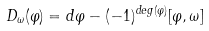<formula> <loc_0><loc_0><loc_500><loc_500>D _ { \omega } ( \varphi ) = d \varphi - ( - 1 ) ^ { d e g ( \varphi ) } [ \varphi , \omega ]</formula> 